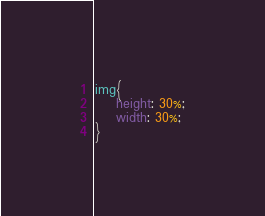<code> <loc_0><loc_0><loc_500><loc_500><_CSS_>img{
    height: 30%;
    width: 30%;
}</code> 